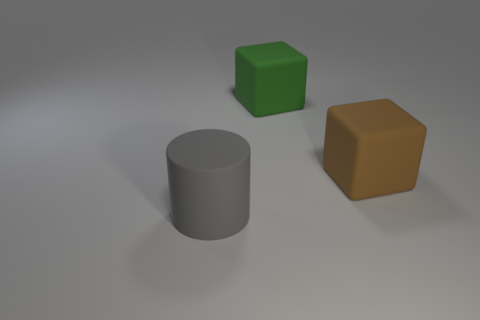There is another object that is the same shape as the large brown rubber object; what is its material?
Ensure brevity in your answer.  Rubber. Are any gray objects visible?
Give a very brief answer. Yes. There is a thing that is both in front of the green object and to the right of the matte cylinder; what size is it?
Provide a short and direct response. Large. The big gray thing has what shape?
Your answer should be compact. Cylinder. Are there any big green rubber cubes in front of the big green thing that is left of the brown object?
Make the answer very short. No. What material is the gray object that is the same size as the green matte object?
Your response must be concise. Rubber. Are there any objects that have the same size as the brown rubber cube?
Your answer should be compact. Yes. What is the big object that is in front of the big brown thing made of?
Your answer should be very brief. Rubber. Are the large object that is left of the big green block and the brown cube made of the same material?
Keep it short and to the point. Yes. What shape is the brown object that is the same size as the green matte thing?
Give a very brief answer. Cube. 